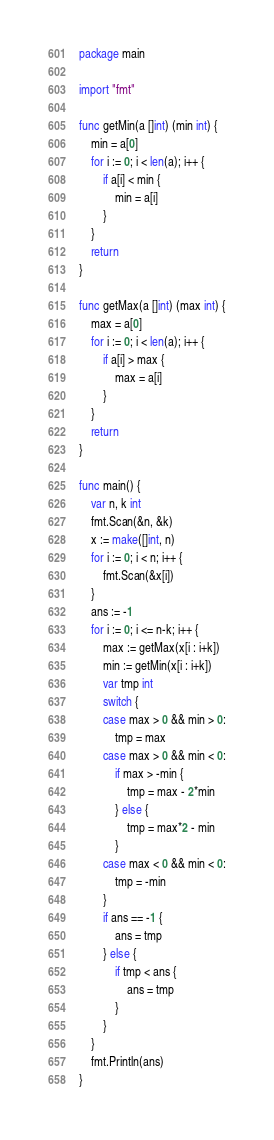Convert code to text. <code><loc_0><loc_0><loc_500><loc_500><_Go_>package main

import "fmt"

func getMin(a []int) (min int) {
	min = a[0]
	for i := 0; i < len(a); i++ {
		if a[i] < min {
			min = a[i]
		}
	}
	return
}

func getMax(a []int) (max int) {
	max = a[0]
	for i := 0; i < len(a); i++ {
		if a[i] > max {
			max = a[i]
		}
	}
	return
}

func main() {
	var n, k int
	fmt.Scan(&n, &k)
	x := make([]int, n)
	for i := 0; i < n; i++ {
		fmt.Scan(&x[i])
	}
	ans := -1
	for i := 0; i <= n-k; i++ {
		max := getMax(x[i : i+k])
		min := getMin(x[i : i+k])
		var tmp int
		switch {
		case max > 0 && min > 0:
			tmp = max
		case max > 0 && min < 0:
			if max > -min {
				tmp = max - 2*min
			} else {
				tmp = max*2 - min
			}
		case max < 0 && min < 0:
			tmp = -min
		}
		if ans == -1 {
			ans = tmp
		} else {
			if tmp < ans {
				ans = tmp
			}
		}
	}
	fmt.Println(ans)
}
</code> 